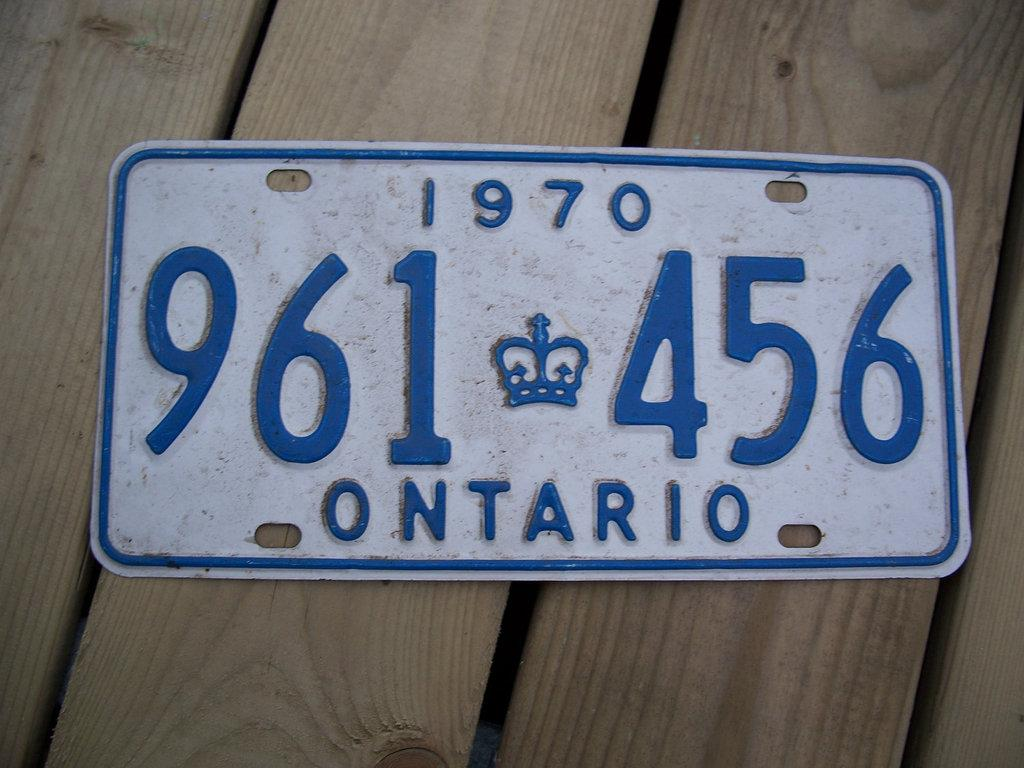<image>
Share a concise interpretation of the image provided. A white license plate says 1970 in blue letters. 